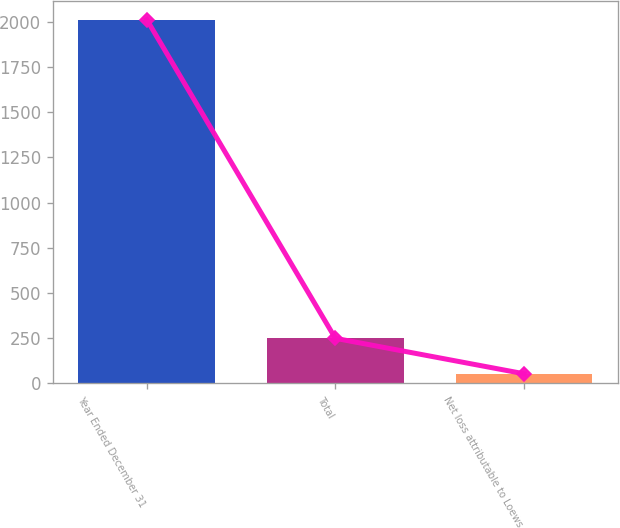Convert chart. <chart><loc_0><loc_0><loc_500><loc_500><bar_chart><fcel>Year Ended December 31<fcel>Total<fcel>Net loss attributable to Loews<nl><fcel>2014<fcel>248.2<fcel>52<nl></chart> 